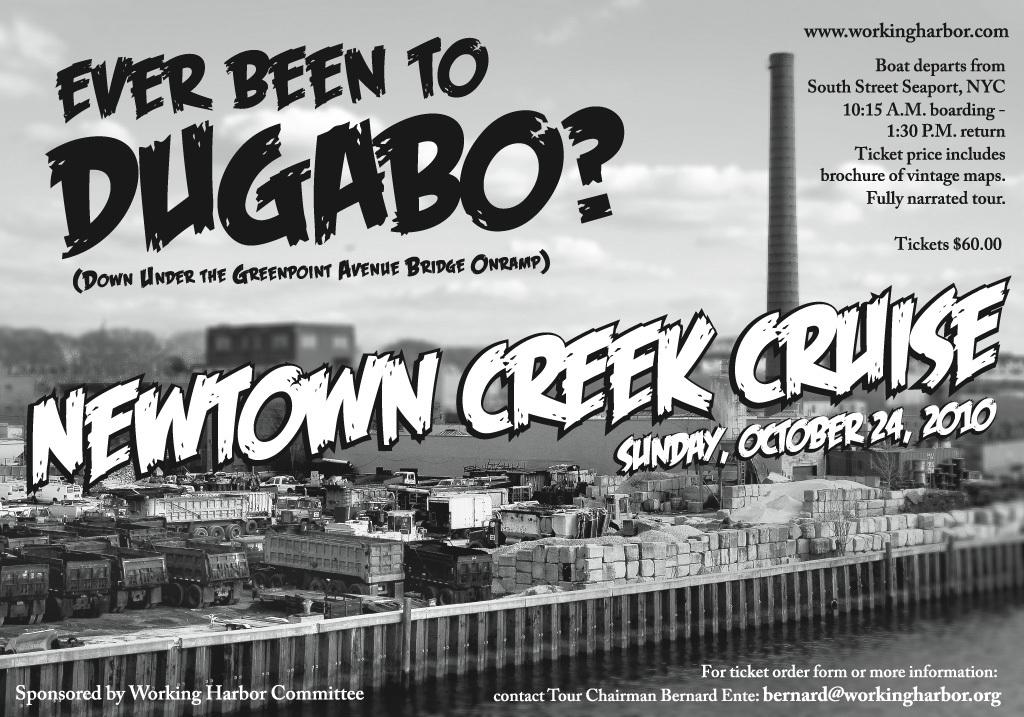What is depicted on the poster in the image? There is a poster of an event in the image. What information can be found on the poster? The poster contains text. What type of material can be seen in the image? There are bricks visible in the image. What else can be seen in the image besides the poster and bricks? There are vehicles in the image. What type of drink is being served by the father in the image? There is no father or drink present in the image. How does the milk affect the appearance of the poster in the image? There is no milk present in the image, so it cannot affect the appearance of the poster. 